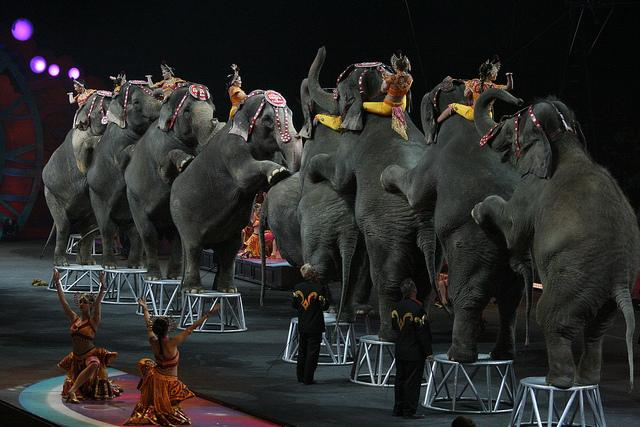What are the elephants doing? performing 